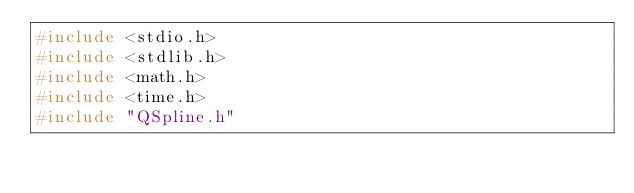Convert code to text. <code><loc_0><loc_0><loc_500><loc_500><_C_>#include <stdio.h>
#include <stdlib.h>
#include <math.h>
#include <time.h>
#include "QSpline.h"</code> 